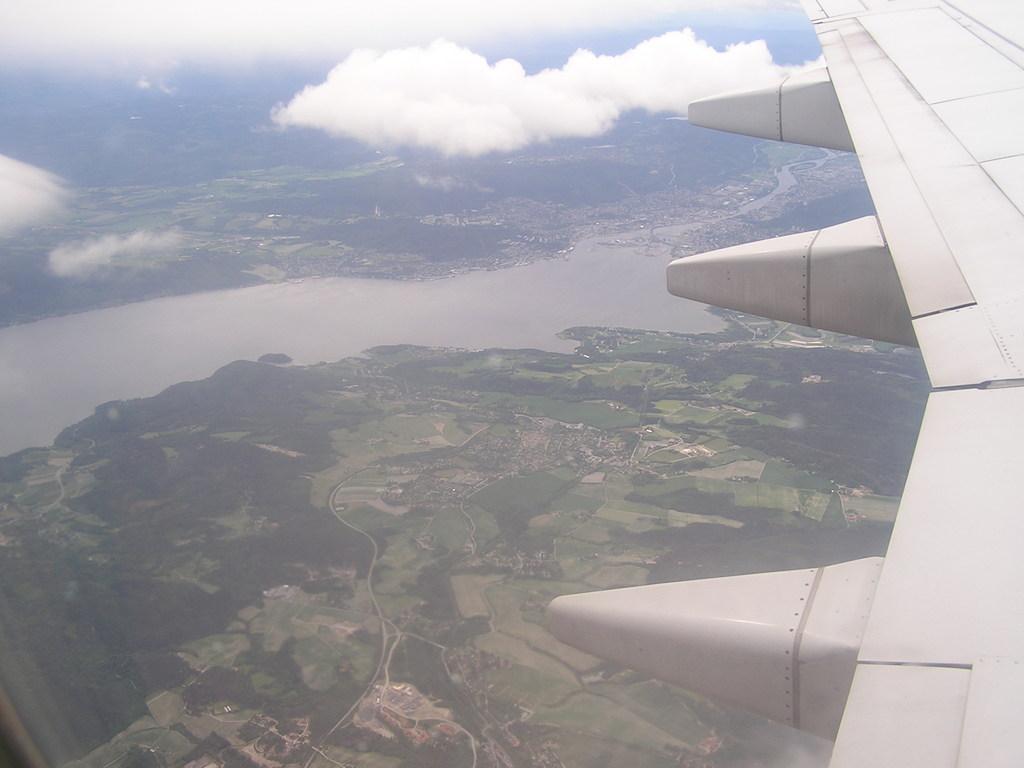Describe this image in one or two sentences. This picture shows an aerial view. We see aeroplane wing and we see clouds, water and trees. 